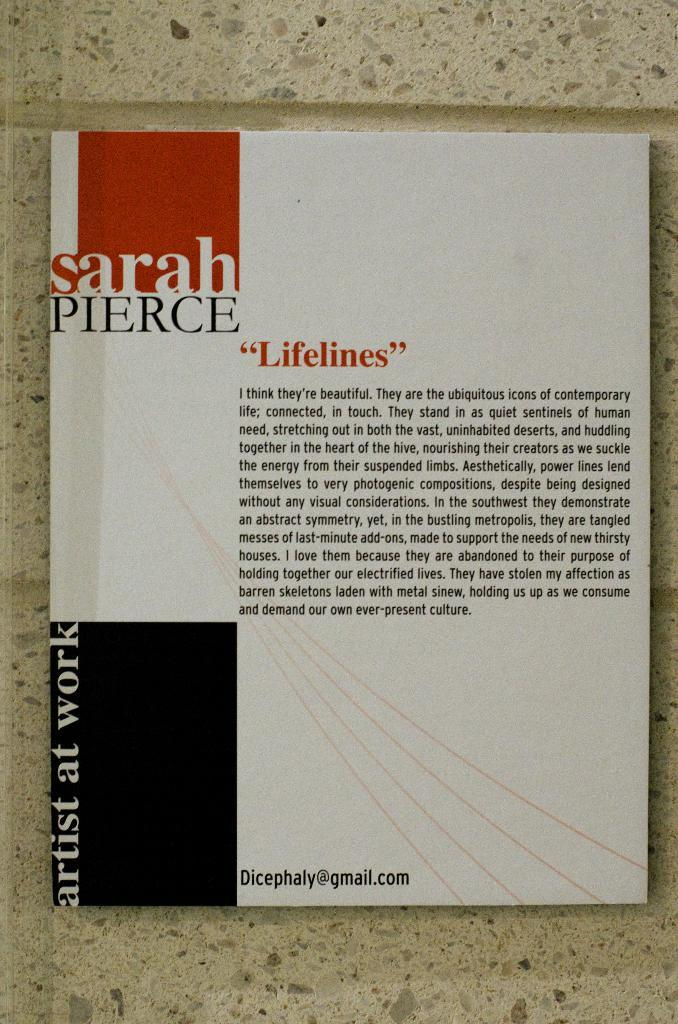<image>
Share a concise interpretation of the image provided. A book of art by Sarah Pierce entitled Lifelines. 